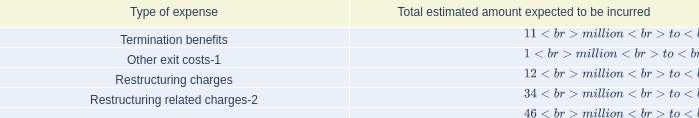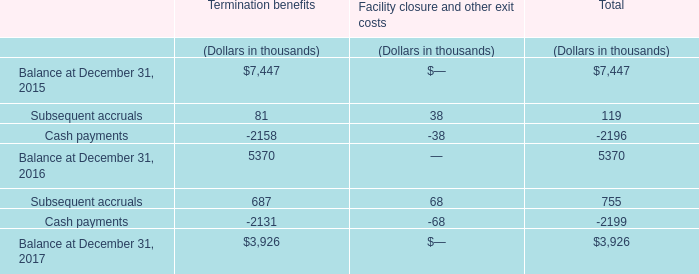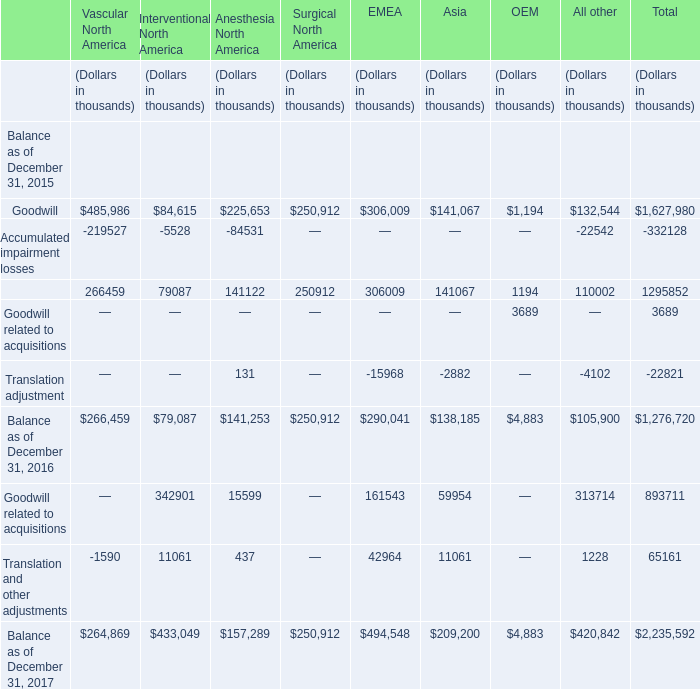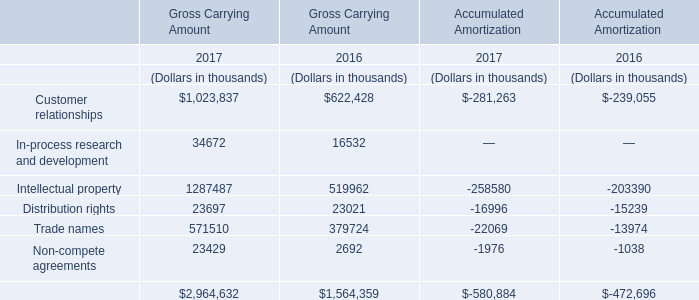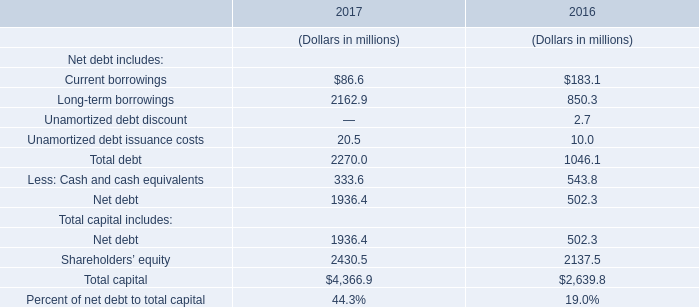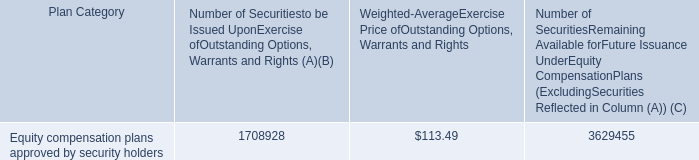what portion of the total number of securities approved by security holders remains available for future issuance? 
Computations: (3629455 / (1708928 + 3629455))
Answer: 0.67988. 